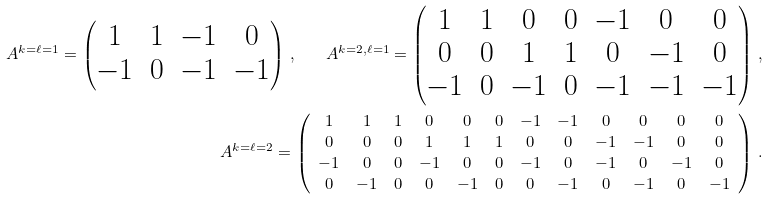Convert formula to latex. <formula><loc_0><loc_0><loc_500><loc_500>A ^ { k = \ell = 1 } = \begin{pmatrix} 1 & 1 & - 1 & 0 \\ - 1 & 0 & - 1 & - 1 \end{pmatrix} \, , \quad A ^ { k = 2 , \ell = 1 } = \begin{pmatrix} 1 & 1 & 0 & 0 & - 1 & 0 & 0 \\ 0 & 0 & 1 & 1 & 0 & - 1 & 0 \\ - 1 & 0 & - 1 & 0 & - 1 & - 1 & - 1 \end{pmatrix} \, , \\ A ^ { k = \ell = 2 } = \left ( \begin{array} { c c c c c c c c c c c c } 1 & 1 & 1 & 0 & 0 & 0 & - 1 & - 1 & 0 & 0 & 0 & 0 \\ 0 & 0 & 0 & 1 & 1 & 1 & 0 & 0 & - 1 & - 1 & 0 & 0 \\ - 1 & 0 & 0 & - 1 & 0 & 0 & - 1 & 0 & - 1 & 0 & - 1 & 0 \\ 0 & - 1 & 0 & 0 & - 1 & 0 & 0 & - 1 & 0 & - 1 & 0 & - 1 \end{array} \right ) \, .</formula> 